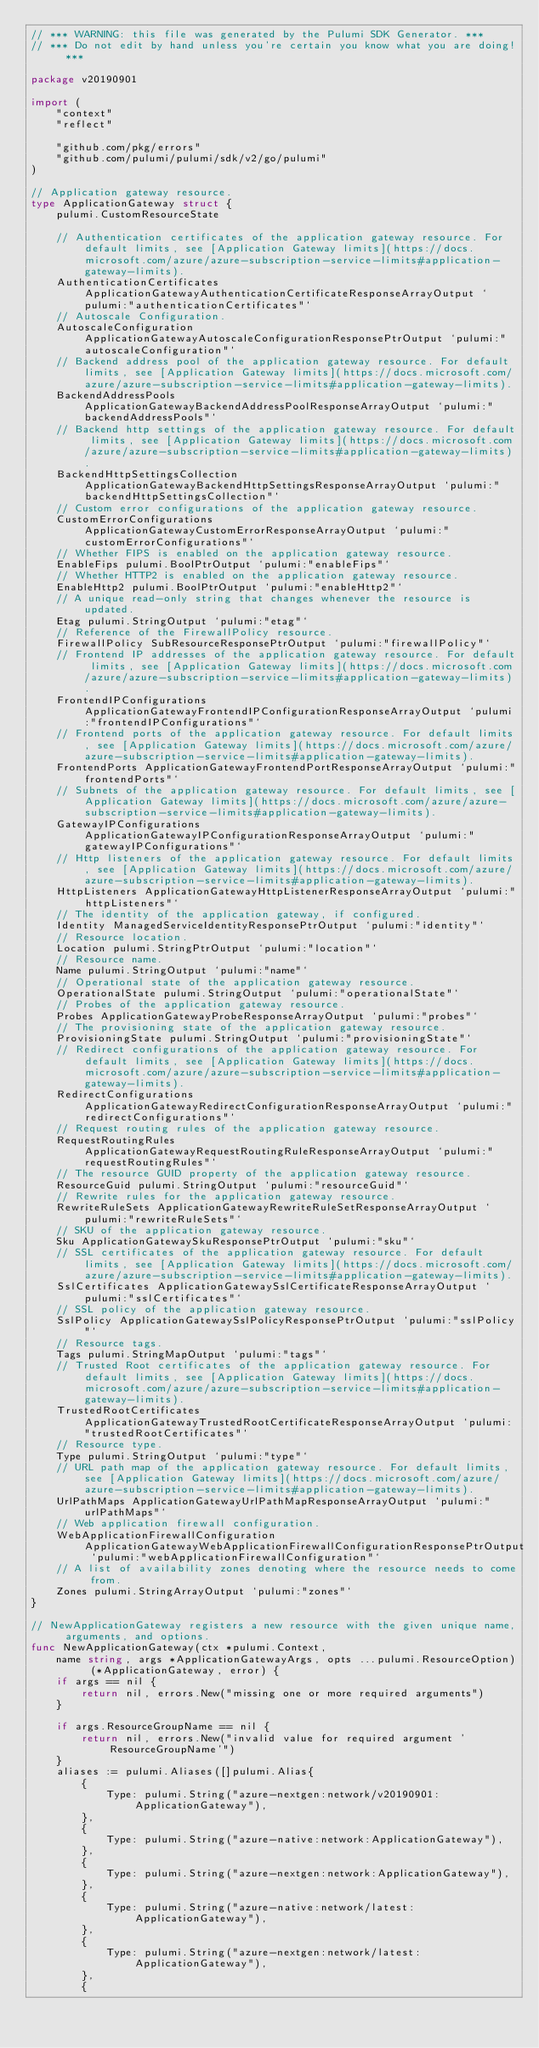Convert code to text. <code><loc_0><loc_0><loc_500><loc_500><_Go_>// *** WARNING: this file was generated by the Pulumi SDK Generator. ***
// *** Do not edit by hand unless you're certain you know what you are doing! ***

package v20190901

import (
	"context"
	"reflect"

	"github.com/pkg/errors"
	"github.com/pulumi/pulumi/sdk/v2/go/pulumi"
)

// Application gateway resource.
type ApplicationGateway struct {
	pulumi.CustomResourceState

	// Authentication certificates of the application gateway resource. For default limits, see [Application Gateway limits](https://docs.microsoft.com/azure/azure-subscription-service-limits#application-gateway-limits).
	AuthenticationCertificates ApplicationGatewayAuthenticationCertificateResponseArrayOutput `pulumi:"authenticationCertificates"`
	// Autoscale Configuration.
	AutoscaleConfiguration ApplicationGatewayAutoscaleConfigurationResponsePtrOutput `pulumi:"autoscaleConfiguration"`
	// Backend address pool of the application gateway resource. For default limits, see [Application Gateway limits](https://docs.microsoft.com/azure/azure-subscription-service-limits#application-gateway-limits).
	BackendAddressPools ApplicationGatewayBackendAddressPoolResponseArrayOutput `pulumi:"backendAddressPools"`
	// Backend http settings of the application gateway resource. For default limits, see [Application Gateway limits](https://docs.microsoft.com/azure/azure-subscription-service-limits#application-gateway-limits).
	BackendHttpSettingsCollection ApplicationGatewayBackendHttpSettingsResponseArrayOutput `pulumi:"backendHttpSettingsCollection"`
	// Custom error configurations of the application gateway resource.
	CustomErrorConfigurations ApplicationGatewayCustomErrorResponseArrayOutput `pulumi:"customErrorConfigurations"`
	// Whether FIPS is enabled on the application gateway resource.
	EnableFips pulumi.BoolPtrOutput `pulumi:"enableFips"`
	// Whether HTTP2 is enabled on the application gateway resource.
	EnableHttp2 pulumi.BoolPtrOutput `pulumi:"enableHttp2"`
	// A unique read-only string that changes whenever the resource is updated.
	Etag pulumi.StringOutput `pulumi:"etag"`
	// Reference of the FirewallPolicy resource.
	FirewallPolicy SubResourceResponsePtrOutput `pulumi:"firewallPolicy"`
	// Frontend IP addresses of the application gateway resource. For default limits, see [Application Gateway limits](https://docs.microsoft.com/azure/azure-subscription-service-limits#application-gateway-limits).
	FrontendIPConfigurations ApplicationGatewayFrontendIPConfigurationResponseArrayOutput `pulumi:"frontendIPConfigurations"`
	// Frontend ports of the application gateway resource. For default limits, see [Application Gateway limits](https://docs.microsoft.com/azure/azure-subscription-service-limits#application-gateway-limits).
	FrontendPorts ApplicationGatewayFrontendPortResponseArrayOutput `pulumi:"frontendPorts"`
	// Subnets of the application gateway resource. For default limits, see [Application Gateway limits](https://docs.microsoft.com/azure/azure-subscription-service-limits#application-gateway-limits).
	GatewayIPConfigurations ApplicationGatewayIPConfigurationResponseArrayOutput `pulumi:"gatewayIPConfigurations"`
	// Http listeners of the application gateway resource. For default limits, see [Application Gateway limits](https://docs.microsoft.com/azure/azure-subscription-service-limits#application-gateway-limits).
	HttpListeners ApplicationGatewayHttpListenerResponseArrayOutput `pulumi:"httpListeners"`
	// The identity of the application gateway, if configured.
	Identity ManagedServiceIdentityResponsePtrOutput `pulumi:"identity"`
	// Resource location.
	Location pulumi.StringPtrOutput `pulumi:"location"`
	// Resource name.
	Name pulumi.StringOutput `pulumi:"name"`
	// Operational state of the application gateway resource.
	OperationalState pulumi.StringOutput `pulumi:"operationalState"`
	// Probes of the application gateway resource.
	Probes ApplicationGatewayProbeResponseArrayOutput `pulumi:"probes"`
	// The provisioning state of the application gateway resource.
	ProvisioningState pulumi.StringOutput `pulumi:"provisioningState"`
	// Redirect configurations of the application gateway resource. For default limits, see [Application Gateway limits](https://docs.microsoft.com/azure/azure-subscription-service-limits#application-gateway-limits).
	RedirectConfigurations ApplicationGatewayRedirectConfigurationResponseArrayOutput `pulumi:"redirectConfigurations"`
	// Request routing rules of the application gateway resource.
	RequestRoutingRules ApplicationGatewayRequestRoutingRuleResponseArrayOutput `pulumi:"requestRoutingRules"`
	// The resource GUID property of the application gateway resource.
	ResourceGuid pulumi.StringOutput `pulumi:"resourceGuid"`
	// Rewrite rules for the application gateway resource.
	RewriteRuleSets ApplicationGatewayRewriteRuleSetResponseArrayOutput `pulumi:"rewriteRuleSets"`
	// SKU of the application gateway resource.
	Sku ApplicationGatewaySkuResponsePtrOutput `pulumi:"sku"`
	// SSL certificates of the application gateway resource. For default limits, see [Application Gateway limits](https://docs.microsoft.com/azure/azure-subscription-service-limits#application-gateway-limits).
	SslCertificates ApplicationGatewaySslCertificateResponseArrayOutput `pulumi:"sslCertificates"`
	// SSL policy of the application gateway resource.
	SslPolicy ApplicationGatewaySslPolicyResponsePtrOutput `pulumi:"sslPolicy"`
	// Resource tags.
	Tags pulumi.StringMapOutput `pulumi:"tags"`
	// Trusted Root certificates of the application gateway resource. For default limits, see [Application Gateway limits](https://docs.microsoft.com/azure/azure-subscription-service-limits#application-gateway-limits).
	TrustedRootCertificates ApplicationGatewayTrustedRootCertificateResponseArrayOutput `pulumi:"trustedRootCertificates"`
	// Resource type.
	Type pulumi.StringOutput `pulumi:"type"`
	// URL path map of the application gateway resource. For default limits, see [Application Gateway limits](https://docs.microsoft.com/azure/azure-subscription-service-limits#application-gateway-limits).
	UrlPathMaps ApplicationGatewayUrlPathMapResponseArrayOutput `pulumi:"urlPathMaps"`
	// Web application firewall configuration.
	WebApplicationFirewallConfiguration ApplicationGatewayWebApplicationFirewallConfigurationResponsePtrOutput `pulumi:"webApplicationFirewallConfiguration"`
	// A list of availability zones denoting where the resource needs to come from.
	Zones pulumi.StringArrayOutput `pulumi:"zones"`
}

// NewApplicationGateway registers a new resource with the given unique name, arguments, and options.
func NewApplicationGateway(ctx *pulumi.Context,
	name string, args *ApplicationGatewayArgs, opts ...pulumi.ResourceOption) (*ApplicationGateway, error) {
	if args == nil {
		return nil, errors.New("missing one or more required arguments")
	}

	if args.ResourceGroupName == nil {
		return nil, errors.New("invalid value for required argument 'ResourceGroupName'")
	}
	aliases := pulumi.Aliases([]pulumi.Alias{
		{
			Type: pulumi.String("azure-nextgen:network/v20190901:ApplicationGateway"),
		},
		{
			Type: pulumi.String("azure-native:network:ApplicationGateway"),
		},
		{
			Type: pulumi.String("azure-nextgen:network:ApplicationGateway"),
		},
		{
			Type: pulumi.String("azure-native:network/latest:ApplicationGateway"),
		},
		{
			Type: pulumi.String("azure-nextgen:network/latest:ApplicationGateway"),
		},
		{</code> 